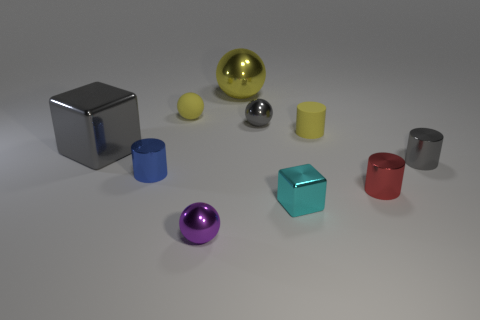Subtract all tiny metal cylinders. How many cylinders are left? 1 Subtract all balls. How many objects are left? 6 Subtract 1 cylinders. How many cylinders are left? 3 Subtract all cyan blocks. How many blue cylinders are left? 1 Subtract all small yellow objects. Subtract all cyan things. How many objects are left? 7 Add 4 small gray objects. How many small gray objects are left? 6 Add 6 purple shiny balls. How many purple shiny balls exist? 7 Subtract all purple spheres. How many spheres are left? 3 Subtract 0 green cylinders. How many objects are left? 10 Subtract all green cylinders. Subtract all green cubes. How many cylinders are left? 4 